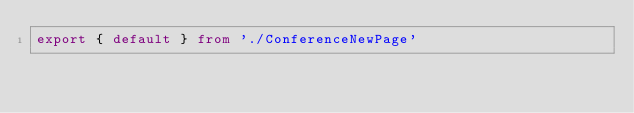Convert code to text. <code><loc_0><loc_0><loc_500><loc_500><_TypeScript_>export { default } from './ConferenceNewPage'
</code> 